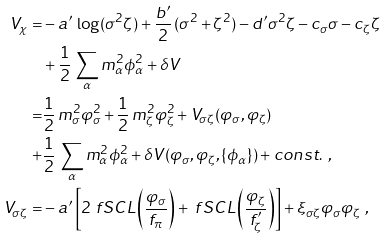Convert formula to latex. <formula><loc_0><loc_0><loc_500><loc_500>V _ { \chi } = & - a ^ { \prime } \, \log ( \sigma ^ { 2 } \zeta ) + \frac { b ^ { \prime } } { 2 } \, ( \sigma ^ { 2 } + \zeta ^ { 2 } ) - d ^ { \prime } \sigma ^ { 2 } \zeta - c _ { \sigma } \sigma - c _ { \zeta } \zeta \\ & + \frac { 1 } { 2 } \, \sum _ { \alpha } m _ { \alpha } ^ { 2 } \phi _ { \alpha } ^ { 2 } + \delta V \\ = & \frac { 1 } { 2 } \, m _ { \sigma } ^ { 2 } \varphi _ { \sigma } ^ { 2 } + \frac { 1 } { 2 } \, m _ { \zeta } ^ { 2 } \varphi _ { \zeta } ^ { 2 } + V _ { \sigma \zeta } ( \varphi _ { \sigma } , \varphi _ { \zeta } ) \\ + & \frac { 1 } { 2 } \, \sum _ { \alpha } m _ { \alpha } ^ { 2 } \phi _ { \alpha } ^ { 2 } + \delta V ( \varphi _ { \sigma } , \varphi _ { \zeta } , \{ \phi _ { \alpha } \} ) + c o n s t . \ , \\ V _ { \sigma \zeta } = & - a ^ { \prime } \left [ 2 \ f S C L \left ( \frac { \varphi _ { \sigma } } { f _ { \pi } } \right ) + \ f S C L \left ( \frac { \varphi _ { \zeta } } { f ^ { \prime } _ { \zeta } } \right ) \right ] + \xi _ { \sigma \zeta } \varphi _ { \sigma } \varphi _ { \zeta } \ ,</formula> 